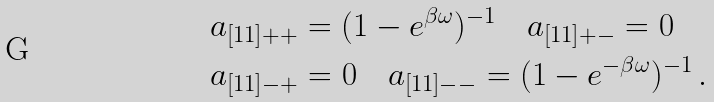Convert formula to latex. <formula><loc_0><loc_0><loc_500><loc_500>& a _ { [ 1 1 ] + + } = ( 1 - e ^ { \beta \omega } ) ^ { - 1 } \quad a _ { [ 1 1 ] + - } = 0 \\ & a _ { [ 1 1 ] - + } = 0 \quad a _ { [ 1 1 ] - - } = ( 1 - e ^ { - \beta \omega } ) ^ { - 1 } \, .</formula> 